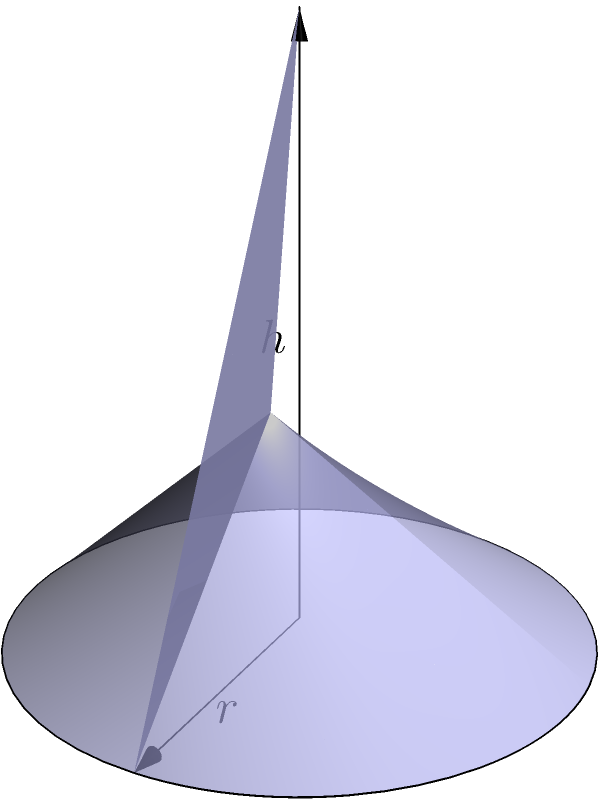In a small village school, a teacher wants to demonstrate the concept of volume using a conical water tank. The tank has a radius of 2 meters and a height of 4 meters. Calculate the volume of water the tank can hold in cubic meters. Use $\pi = 3.14$ for your calculations. To calculate the volume of a cone, we use the formula:

$$V = \frac{1}{3}\pi r^2 h$$

Where:
$V$ = volume
$r$ = radius of the base
$h$ = height of the cone

Given:
$r = 2$ meters
$h = 4$ meters
$\pi = 3.14$

Let's substitute these values into the formula:

$$V = \frac{1}{3} \times 3.14 \times 2^2 \times 4$$

Now, let's solve step by step:

1) First, calculate $r^2$:
   $2^2 = 4$

2) Multiply all the numbers:
   $\frac{1}{3} \times 3.14 \times 4 \times 4 = 16.75$

Therefore, the volume of the conical water tank is 16.75 cubic meters.
Answer: $16.75$ cubic meters 